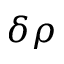Convert formula to latex. <formula><loc_0><loc_0><loc_500><loc_500>\delta \rho</formula> 